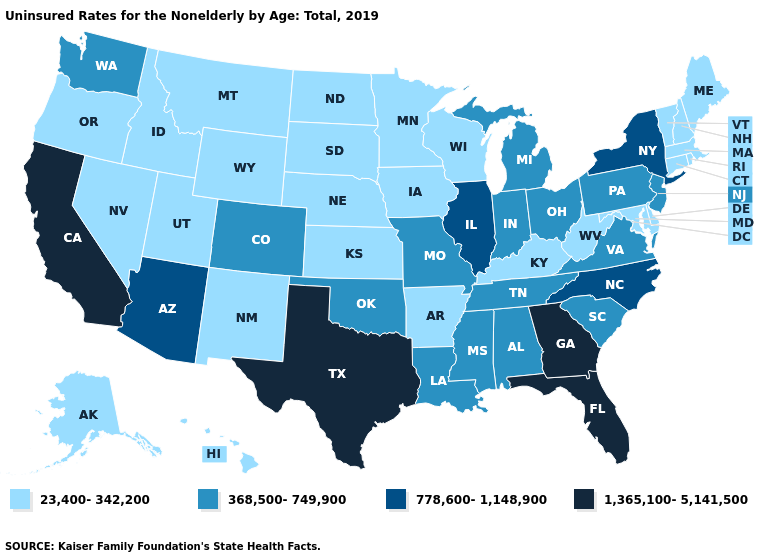Which states have the lowest value in the MidWest?
Quick response, please. Iowa, Kansas, Minnesota, Nebraska, North Dakota, South Dakota, Wisconsin. Name the states that have a value in the range 1,365,100-5,141,500?
Give a very brief answer. California, Florida, Georgia, Texas. Which states hav the highest value in the MidWest?
Concise answer only. Illinois. Does Texas have the highest value in the USA?
Give a very brief answer. Yes. Name the states that have a value in the range 778,600-1,148,900?
Keep it brief. Arizona, Illinois, New York, North Carolina. What is the value of West Virginia?
Answer briefly. 23,400-342,200. What is the value of South Carolina?
Short answer required. 368,500-749,900. Name the states that have a value in the range 1,365,100-5,141,500?
Concise answer only. California, Florida, Georgia, Texas. What is the lowest value in the USA?
Quick response, please. 23,400-342,200. What is the lowest value in the MidWest?
Answer briefly. 23,400-342,200. Name the states that have a value in the range 1,365,100-5,141,500?
Be succinct. California, Florida, Georgia, Texas. What is the highest value in states that border Oklahoma?
Be succinct. 1,365,100-5,141,500. Name the states that have a value in the range 1,365,100-5,141,500?
Write a very short answer. California, Florida, Georgia, Texas. Among the states that border Minnesota , which have the highest value?
Give a very brief answer. Iowa, North Dakota, South Dakota, Wisconsin. 